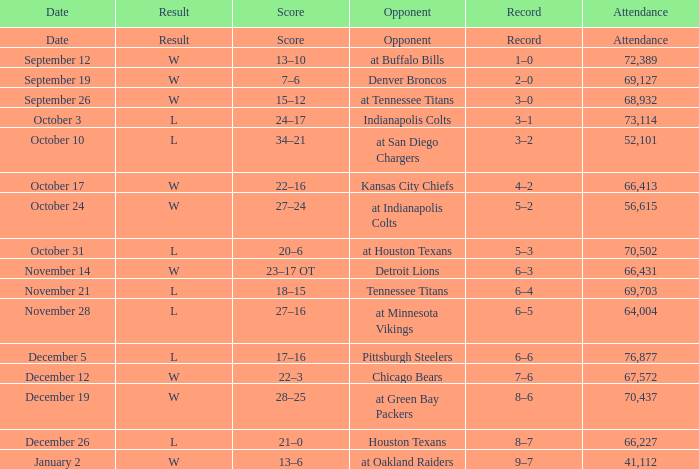Would you be able to parse every entry in this table? {'header': ['Date', 'Result', 'Score', 'Opponent', 'Record', 'Attendance'], 'rows': [['Date', 'Result', 'Score', 'Opponent', 'Record', 'Attendance'], ['September 12', 'W', '13–10', 'at Buffalo Bills', '1–0', '72,389'], ['September 19', 'W', '7–6', 'Denver Broncos', '2–0', '69,127'], ['September 26', 'W', '15–12', 'at Tennessee Titans', '3–0', '68,932'], ['October 3', 'L', '24–17', 'Indianapolis Colts', '3–1', '73,114'], ['October 10', 'L', '34–21', 'at San Diego Chargers', '3–2', '52,101'], ['October 17', 'W', '22–16', 'Kansas City Chiefs', '4–2', '66,413'], ['October 24', 'W', '27–24', 'at Indianapolis Colts', '5–2', '56,615'], ['October 31', 'L', '20–6', 'at Houston Texans', '5–3', '70,502'], ['November 14', 'W', '23–17 OT', 'Detroit Lions', '6–3', '66,431'], ['November 21', 'L', '18–15', 'Tennessee Titans', '6–4', '69,703'], ['November 28', 'L', '27–16', 'at Minnesota Vikings', '6–5', '64,004'], ['December 5', 'L', '17–16', 'Pittsburgh Steelers', '6–6', '76,877'], ['December 12', 'W', '22–3', 'Chicago Bears', '7–6', '67,572'], ['December 19', 'W', '28–25', 'at Green Bay Packers', '8–6', '70,437'], ['December 26', 'L', '21–0', 'Houston Texans', '8–7', '66,227'], ['January 2', 'W', '13–6', 'at Oakland Raiders', '9–7', '41,112']]} What attendance has detroit lions as the opponent? 66431.0. 